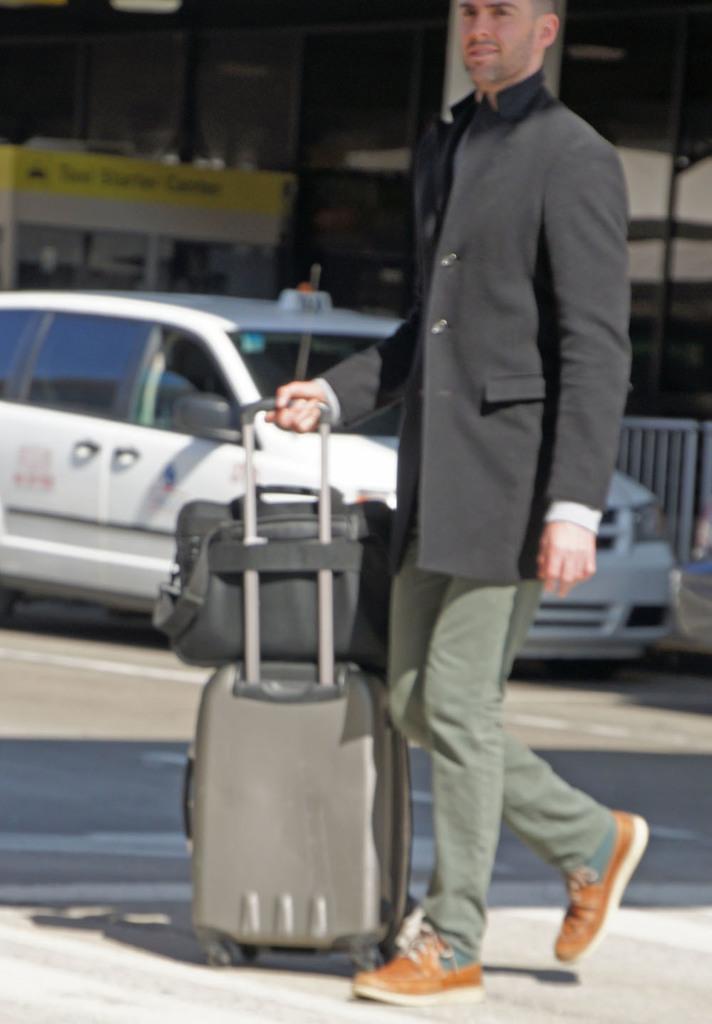Can you describe this image briefly? In the image we can see there is a person who is standing and he is holding travelling back and suitcase and beside there is car which is parked on the road. 